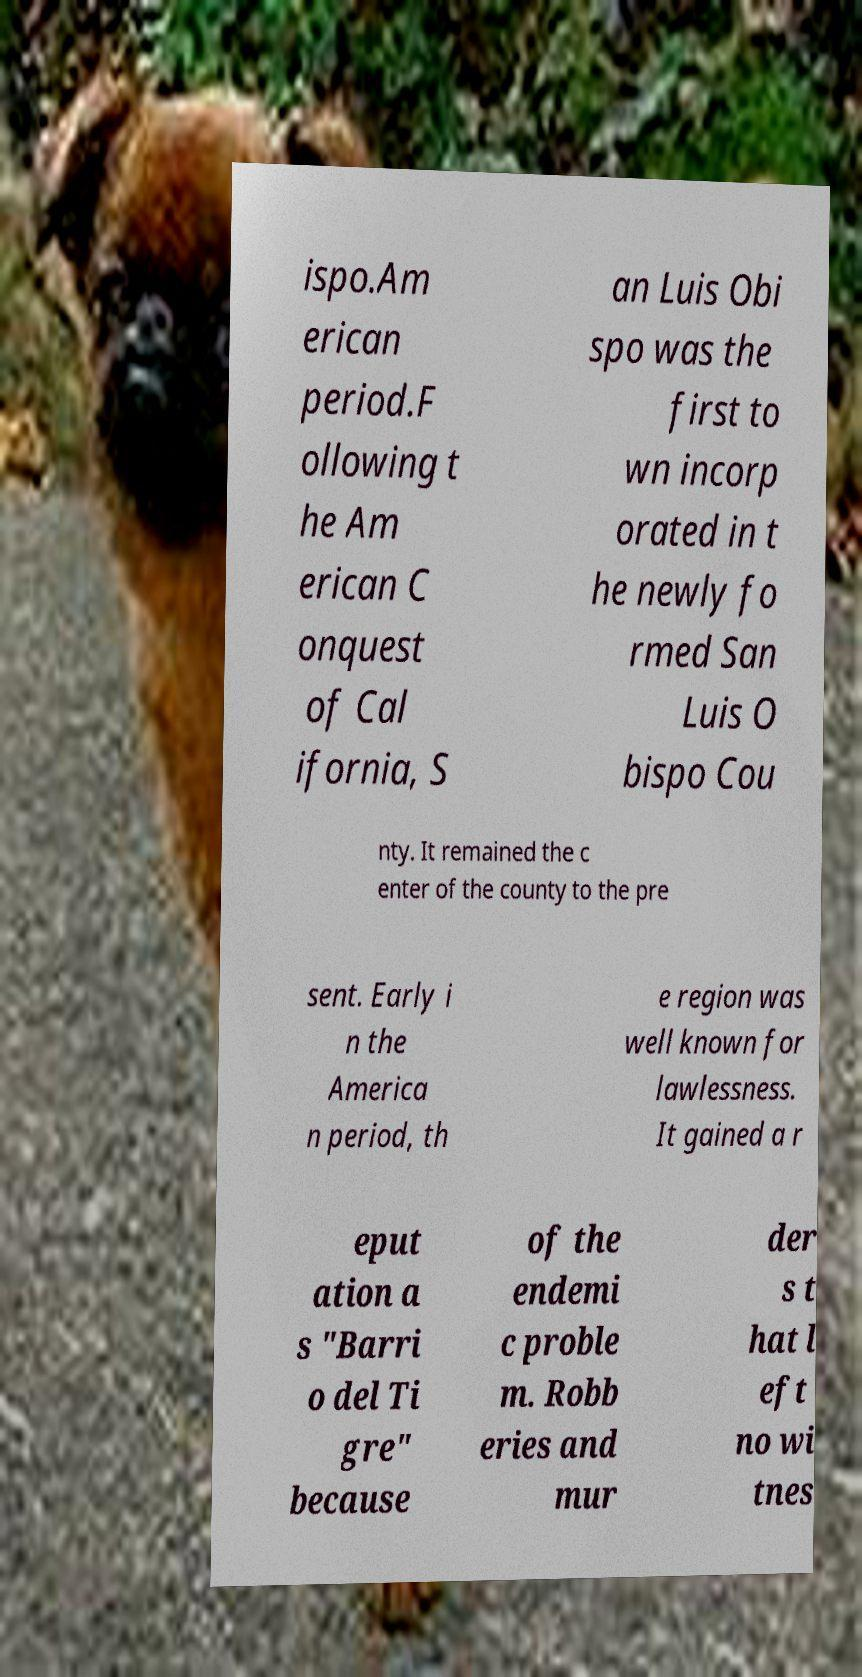I need the written content from this picture converted into text. Can you do that? ispo.Am erican period.F ollowing t he Am erican C onquest of Cal ifornia, S an Luis Obi spo was the first to wn incorp orated in t he newly fo rmed San Luis O bispo Cou nty. It remained the c enter of the county to the pre sent. Early i n the America n period, th e region was well known for lawlessness. It gained a r eput ation a s "Barri o del Ti gre" because of the endemi c proble m. Robb eries and mur der s t hat l eft no wi tnes 